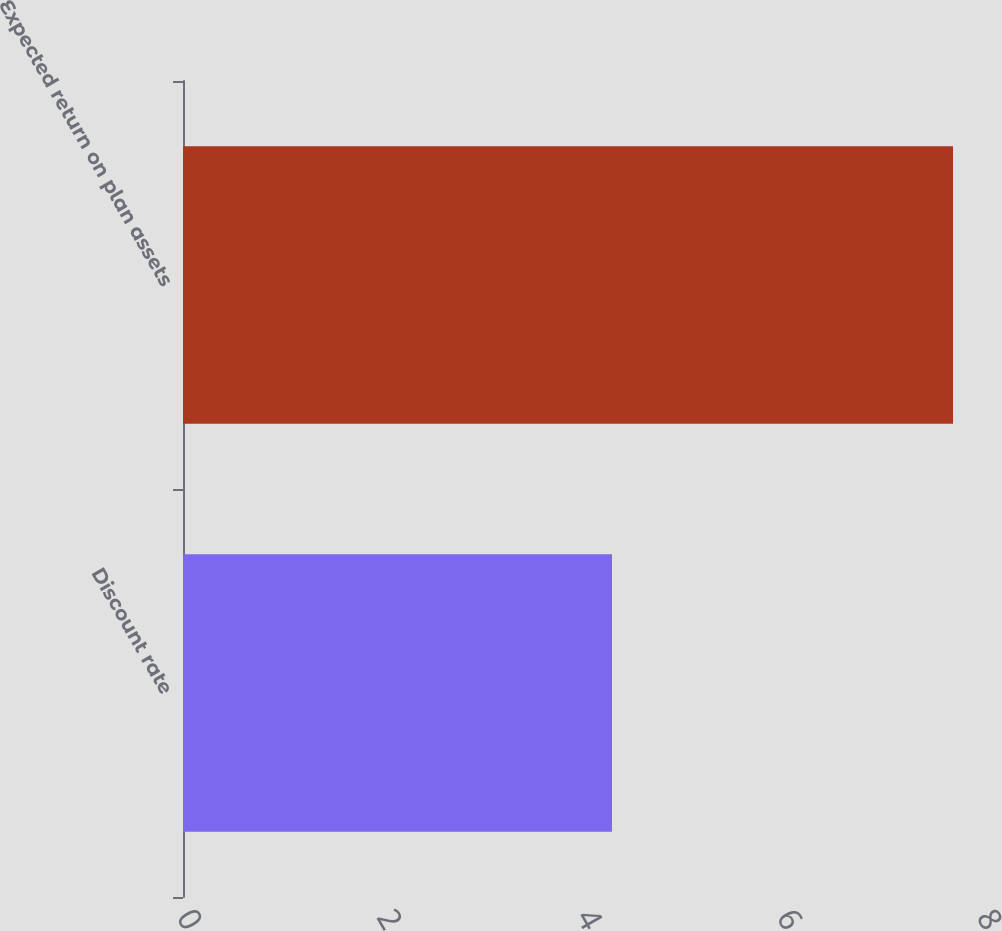Convert chart to OTSL. <chart><loc_0><loc_0><loc_500><loc_500><bar_chart><fcel>Discount rate<fcel>Expected return on plan assets<nl><fcel>4.29<fcel>7.7<nl></chart> 